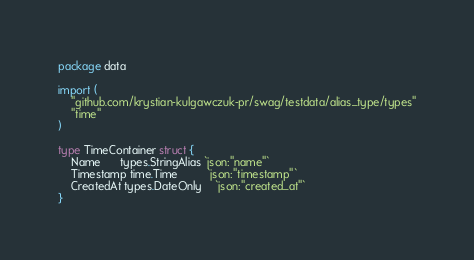Convert code to text. <code><loc_0><loc_0><loc_500><loc_500><_Go_>package data

import (
	"github.com/krystian-kulgawczuk-pr/swag/testdata/alias_type/types"
	"time"
)

type TimeContainer struct {
	Name      types.StringAlias `json:"name"`
	Timestamp time.Time         `json:"timestamp"`
	CreatedAt types.DateOnly    `json:"created_at"`
}
</code> 